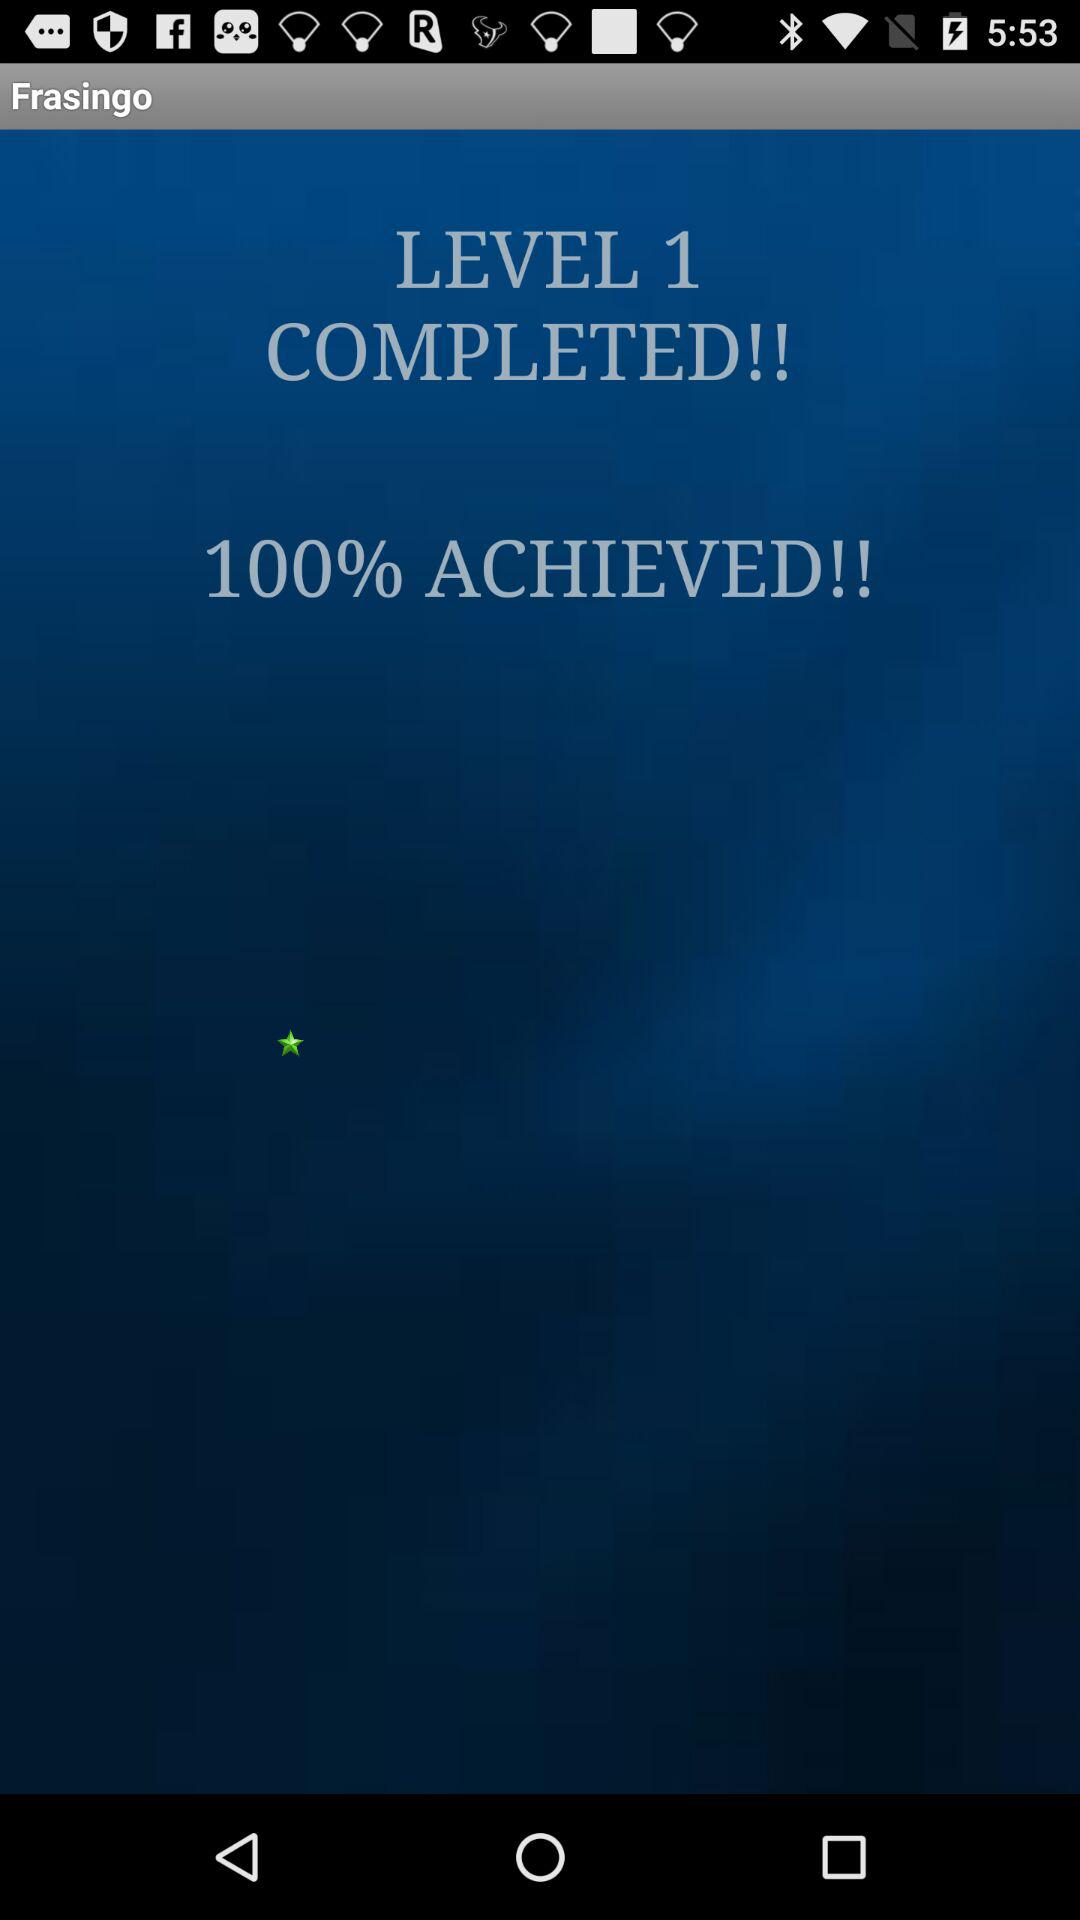Which level is completed? The completed level is 1. 